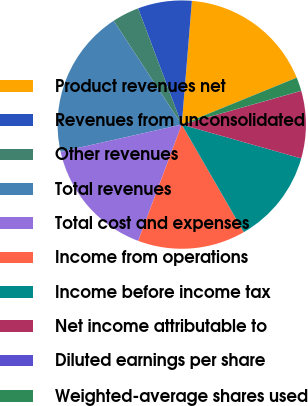<chart> <loc_0><loc_0><loc_500><loc_500><pie_chart><fcel>Product revenues net<fcel>Revenues from unconsolidated<fcel>Other revenues<fcel>Total revenues<fcel>Total cost and expenses<fcel>Income from operations<fcel>Income before income tax<fcel>Net income attributable to<fcel>Diluted earnings per share<fcel>Weighted-average shares used<nl><fcel>17.53%<fcel>7.02%<fcel>3.52%<fcel>19.28%<fcel>15.78%<fcel>14.03%<fcel>12.28%<fcel>8.77%<fcel>0.02%<fcel>1.77%<nl></chart> 